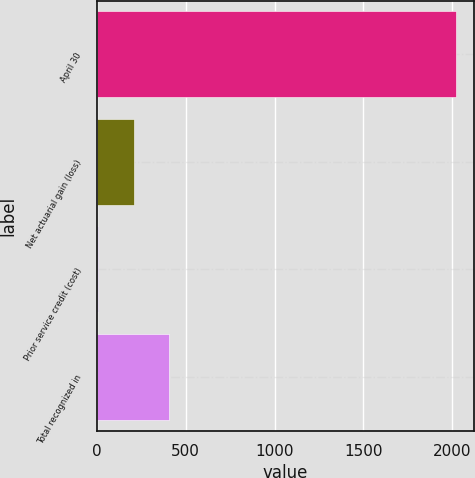<chart> <loc_0><loc_0><loc_500><loc_500><bar_chart><fcel>April 30<fcel>Net actuarial gain (loss)<fcel>Prior service credit (cost)<fcel>Total recognized in<nl><fcel>2019<fcel>207.12<fcel>5.8<fcel>408.44<nl></chart> 